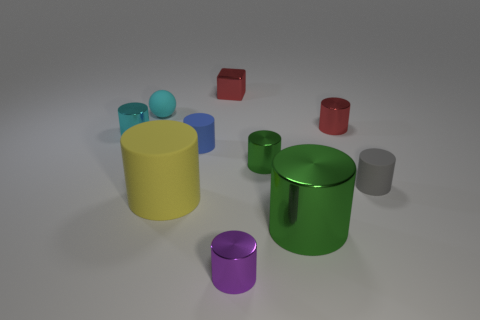Subtract all red metal cylinders. How many cylinders are left? 7 Subtract all red cubes. How many purple cylinders are left? 1 Subtract all gray rubber cylinders. Subtract all blue matte objects. How many objects are left? 8 Add 1 blue matte cylinders. How many blue matte cylinders are left? 2 Add 6 small blue rubber things. How many small blue rubber things exist? 7 Subtract all green cylinders. How many cylinders are left? 6 Subtract 1 purple cylinders. How many objects are left? 9 Subtract all spheres. How many objects are left? 9 Subtract 1 cubes. How many cubes are left? 0 Subtract all brown spheres. Subtract all green cylinders. How many spheres are left? 1 